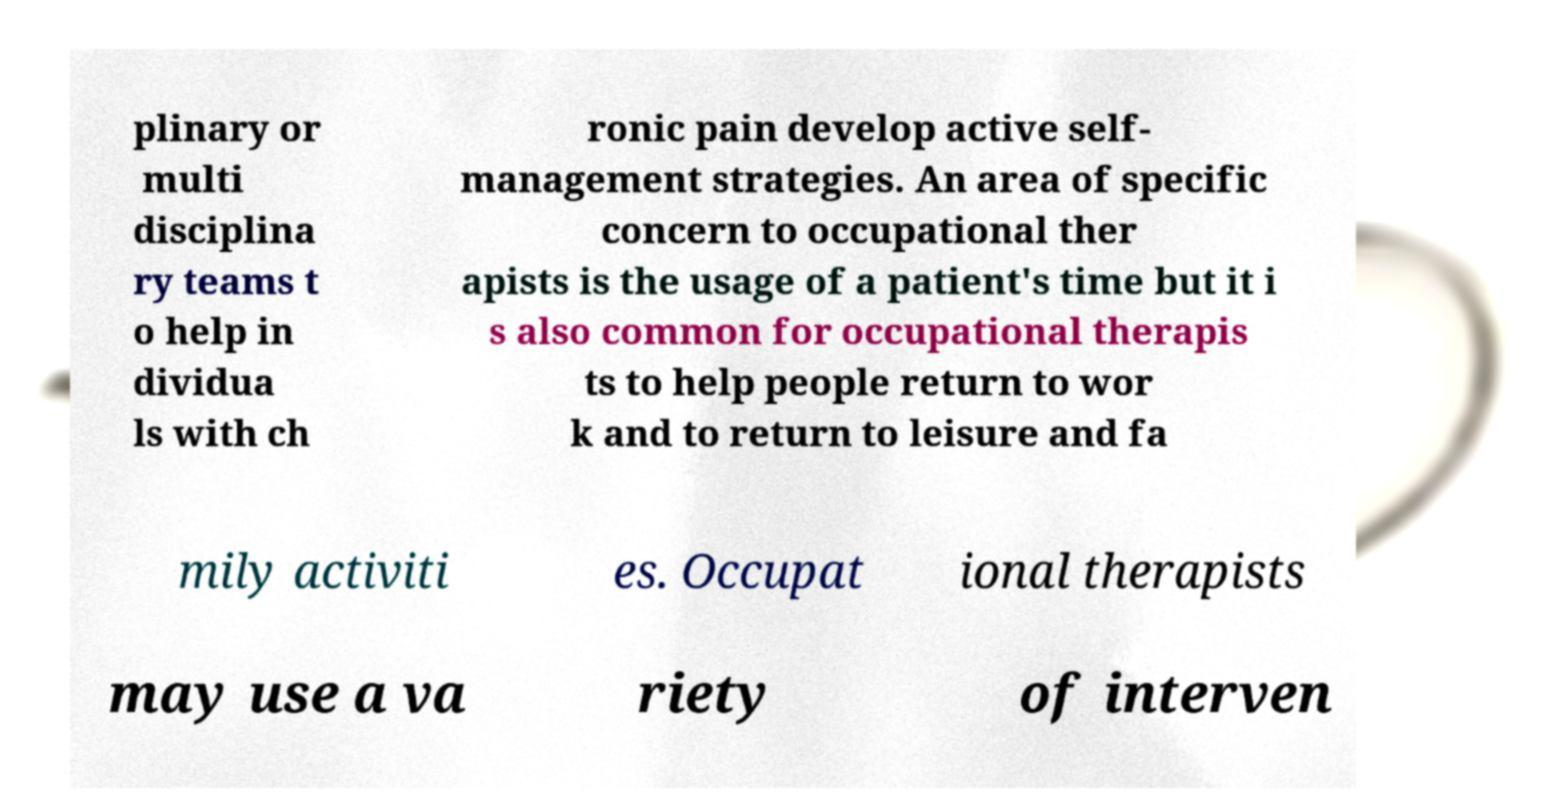What messages or text are displayed in this image? I need them in a readable, typed format. plinary or multi disciplina ry teams t o help in dividua ls with ch ronic pain develop active self- management strategies. An area of specific concern to occupational ther apists is the usage of a patient's time but it i s also common for occupational therapis ts to help people return to wor k and to return to leisure and fa mily activiti es. Occupat ional therapists may use a va riety of interven 